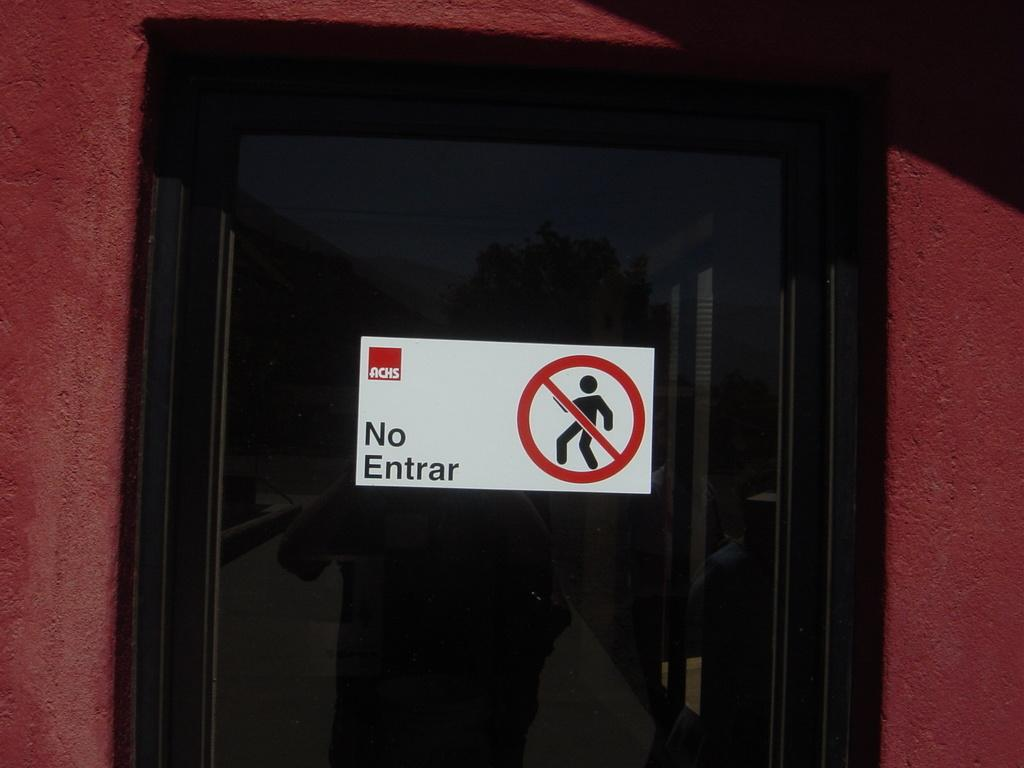What is the main subject of the image? There is a black thing in the image. What can be seen on the black thing? The black thing has a sticker on it, and there are words visible on it. What else is present in the image? There is a sign in the image. What is the color of the surface the black thing is on? The black thing is on a maroon color surface. What type of bread can be seen growing on the plants in the image? There are no plants or bread present in the image; it only features a black thing with a sticker and words, a sign, and a maroon color surface. 